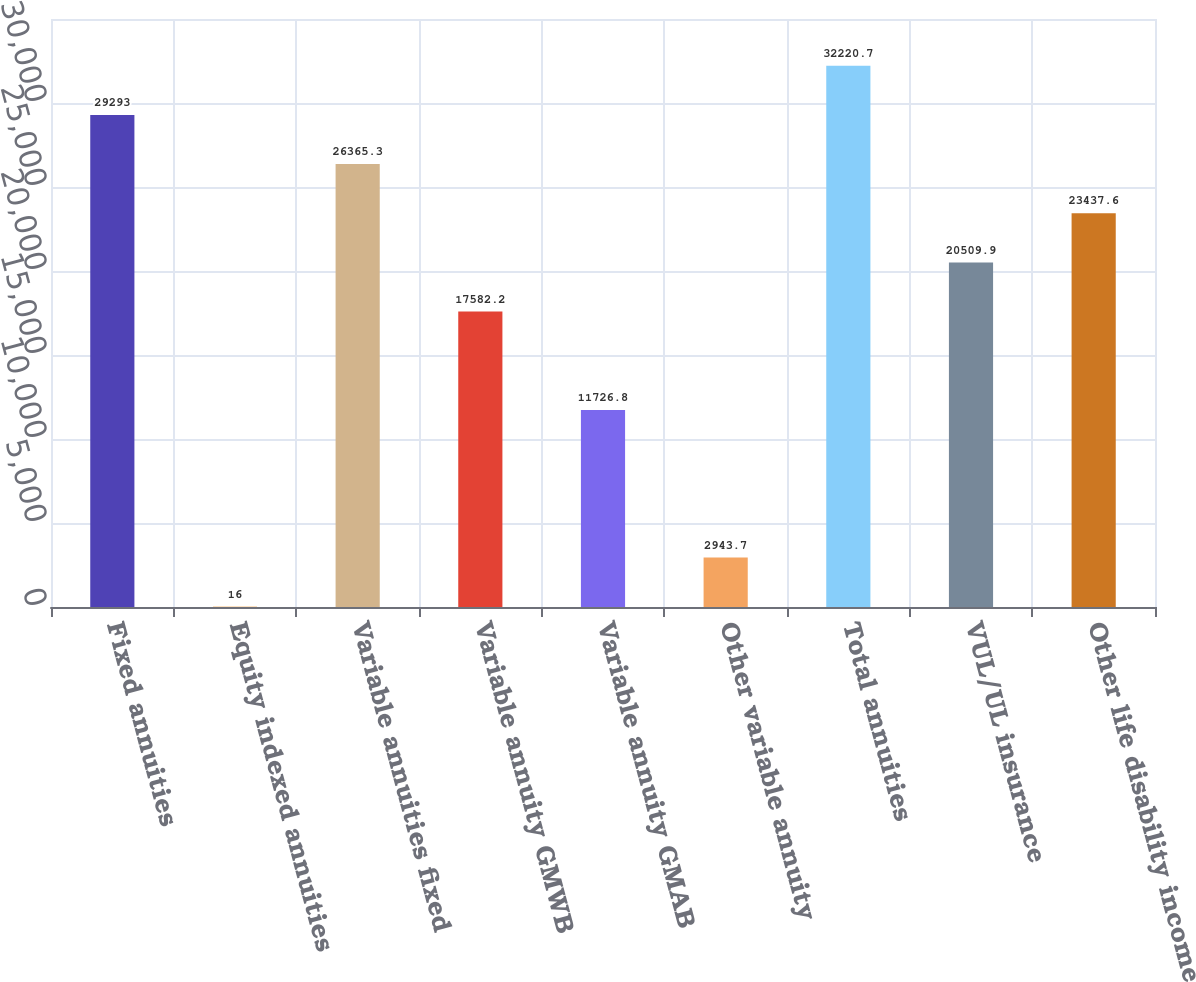Convert chart. <chart><loc_0><loc_0><loc_500><loc_500><bar_chart><fcel>Fixed annuities<fcel>Equity indexed annuities<fcel>Variable annuities fixed<fcel>Variable annuity GMWB<fcel>Variable annuity GMAB<fcel>Other variable annuity<fcel>Total annuities<fcel>VUL/UL insurance<fcel>Other life disability income<nl><fcel>29293<fcel>16<fcel>26365.3<fcel>17582.2<fcel>11726.8<fcel>2943.7<fcel>32220.7<fcel>20509.9<fcel>23437.6<nl></chart> 